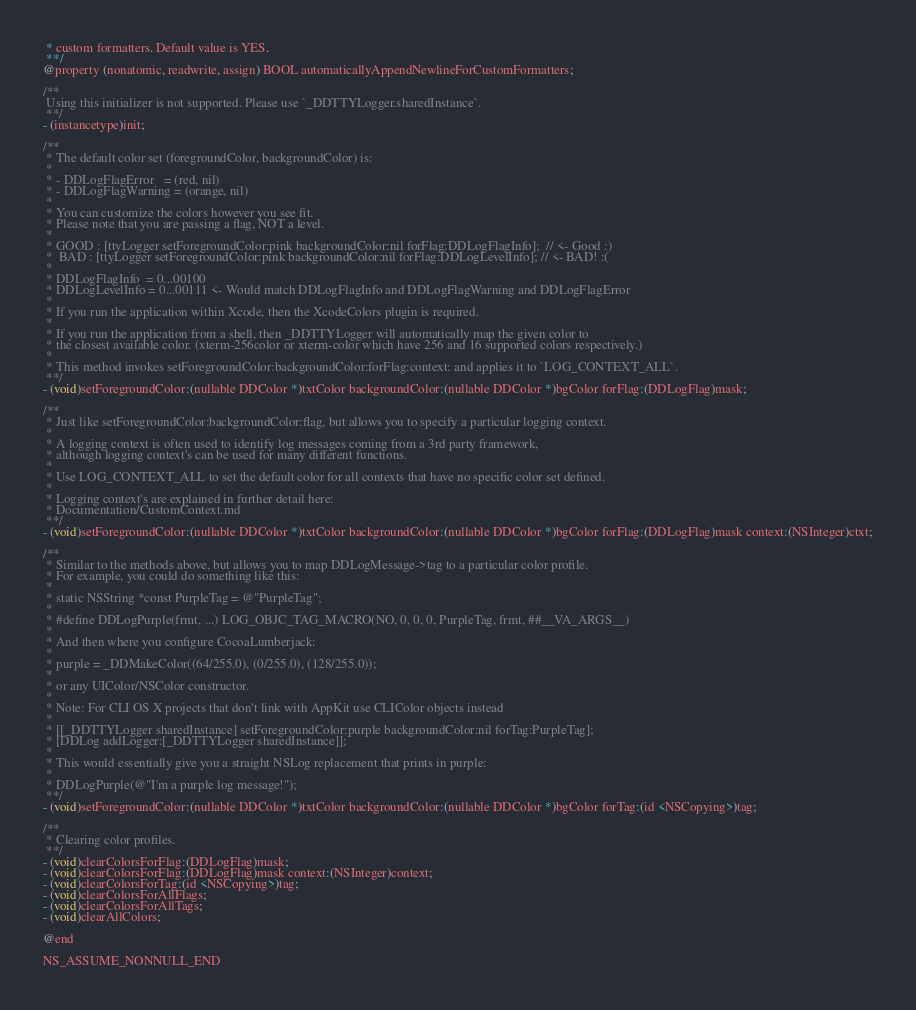<code> <loc_0><loc_0><loc_500><loc_500><_C_> * custom formatters. Default value is YES.
 **/
@property (nonatomic, readwrite, assign) BOOL automaticallyAppendNewlineForCustomFormatters;

/**
 Using this initializer is not supported. Please use `_DDTTYLogger.sharedInstance`.
 **/
- (instancetype)init;

/**
 * The default color set (foregroundColor, backgroundColor) is:
 *
 * - DDLogFlagError   = (red, nil)
 * - DDLogFlagWarning = (orange, nil)
 *
 * You can customize the colors however you see fit.
 * Please note that you are passing a flag, NOT a level.
 *
 * GOOD : [ttyLogger setForegroundColor:pink backgroundColor:nil forFlag:DDLogFlagInfo];  // <- Good :)
 *  BAD : [ttyLogger setForegroundColor:pink backgroundColor:nil forFlag:DDLogLevelInfo]; // <- BAD! :(
 *
 * DDLogFlagInfo  = 0...00100
 * DDLogLevelInfo = 0...00111 <- Would match DDLogFlagInfo and DDLogFlagWarning and DDLogFlagError
 *
 * If you run the application within Xcode, then the XcodeColors plugin is required.
 *
 * If you run the application from a shell, then _DDTTYLogger will automatically map the given color to
 * the closest available color. (xterm-256color or xterm-color which have 256 and 16 supported colors respectively.)
 *
 * This method invokes setForegroundColor:backgroundColor:forFlag:context: and applies it to `LOG_CONTEXT_ALL`.
 **/
- (void)setForegroundColor:(nullable DDColor *)txtColor backgroundColor:(nullable DDColor *)bgColor forFlag:(DDLogFlag)mask;

/**
 * Just like setForegroundColor:backgroundColor:flag, but allows you to specify a particular logging context.
 *
 * A logging context is often used to identify log messages coming from a 3rd party framework,
 * although logging context's can be used for many different functions.
 *
 * Use LOG_CONTEXT_ALL to set the default color for all contexts that have no specific color set defined.
 *
 * Logging context's are explained in further detail here:
 * Documentation/CustomContext.md
 **/
- (void)setForegroundColor:(nullable DDColor *)txtColor backgroundColor:(nullable DDColor *)bgColor forFlag:(DDLogFlag)mask context:(NSInteger)ctxt;

/**
 * Similar to the methods above, but allows you to map DDLogMessage->tag to a particular color profile.
 * For example, you could do something like this:
 *
 * static NSString *const PurpleTag = @"PurpleTag";
 *
 * #define DDLogPurple(frmt, ...) LOG_OBJC_TAG_MACRO(NO, 0, 0, 0, PurpleTag, frmt, ##__VA_ARGS__)
 *
 * And then where you configure CocoaLumberjack:
 *
 * purple = _DDMakeColor((64/255.0), (0/255.0), (128/255.0));
 *
 * or any UIColor/NSColor constructor.
 *
 * Note: For CLI OS X projects that don't link with AppKit use CLIColor objects instead
 *
 * [[_DDTTYLogger sharedInstance] setForegroundColor:purple backgroundColor:nil forTag:PurpleTag];
 * [DDLog addLogger:[_DDTTYLogger sharedInstance]];
 *
 * This would essentially give you a straight NSLog replacement that prints in purple:
 *
 * DDLogPurple(@"I'm a purple log message!");
 **/
- (void)setForegroundColor:(nullable DDColor *)txtColor backgroundColor:(nullable DDColor *)bgColor forTag:(id <NSCopying>)tag;

/**
 * Clearing color profiles.
 **/
- (void)clearColorsForFlag:(DDLogFlag)mask;
- (void)clearColorsForFlag:(DDLogFlag)mask context:(NSInteger)context;
- (void)clearColorsForTag:(id <NSCopying>)tag;
- (void)clearColorsForAllFlags;
- (void)clearColorsForAllTags;
- (void)clearAllColors;

@end

NS_ASSUME_NONNULL_END
</code> 